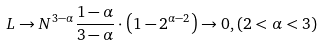<formula> <loc_0><loc_0><loc_500><loc_500>L \rightarrow N ^ { 3 - \alpha } \frac { 1 - \alpha } { 3 - \alpha } \cdot \left ( 1 - 2 ^ { \alpha - 2 } \right ) \rightarrow 0 , \left ( 2 < \alpha < 3 \right )</formula> 